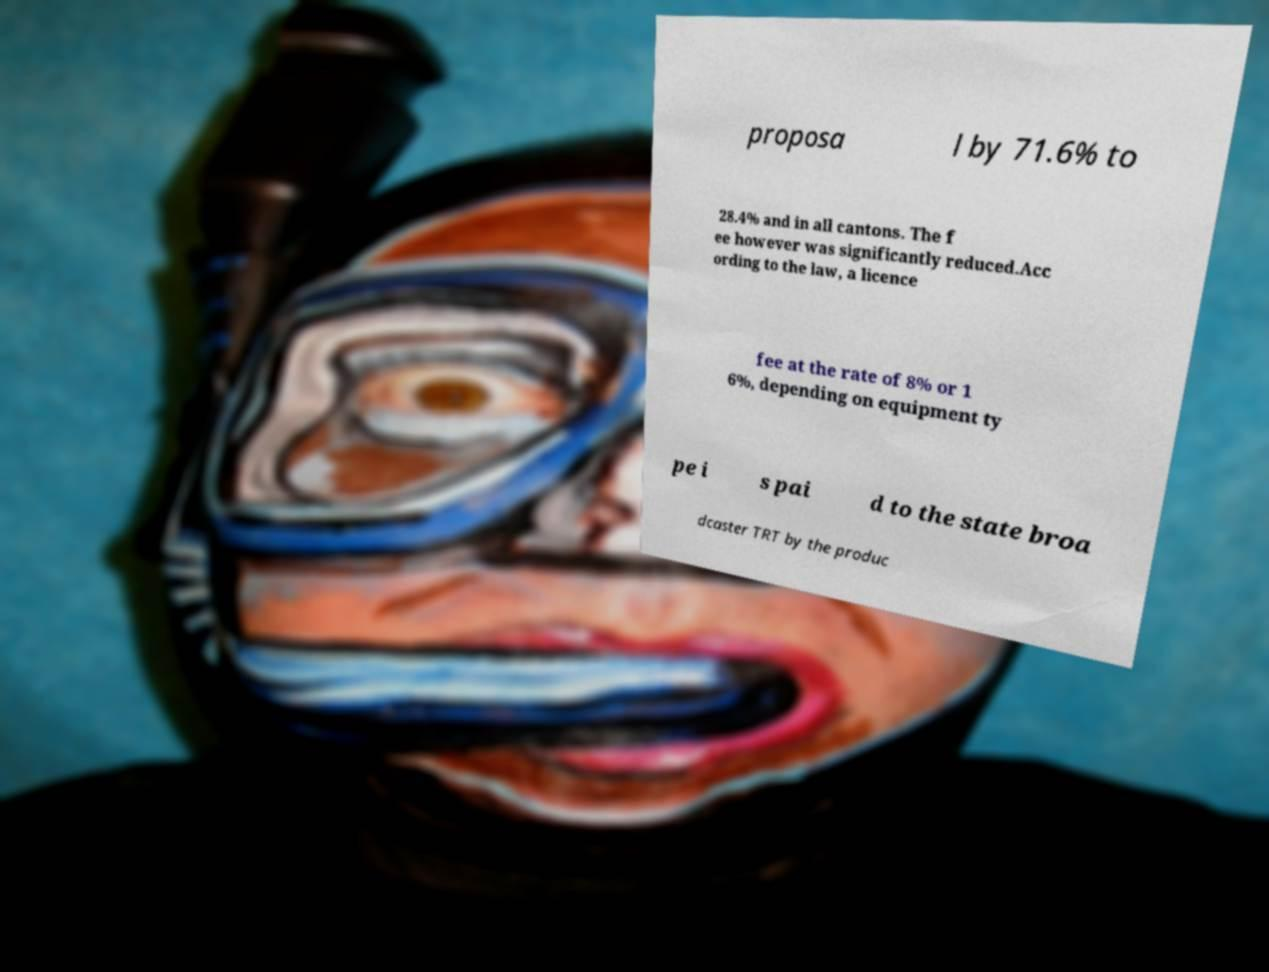Could you assist in decoding the text presented in this image and type it out clearly? proposa l by 71.6% to 28.4% and in all cantons. The f ee however was significantly reduced.Acc ording to the law, a licence fee at the rate of 8% or 1 6%, depending on equipment ty pe i s pai d to the state broa dcaster TRT by the produc 